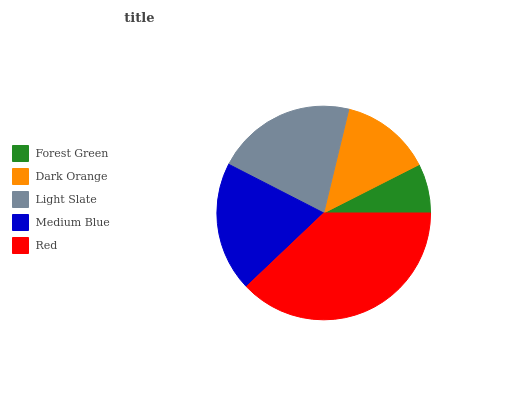Is Forest Green the minimum?
Answer yes or no. Yes. Is Red the maximum?
Answer yes or no. Yes. Is Dark Orange the minimum?
Answer yes or no. No. Is Dark Orange the maximum?
Answer yes or no. No. Is Dark Orange greater than Forest Green?
Answer yes or no. Yes. Is Forest Green less than Dark Orange?
Answer yes or no. Yes. Is Forest Green greater than Dark Orange?
Answer yes or no. No. Is Dark Orange less than Forest Green?
Answer yes or no. No. Is Medium Blue the high median?
Answer yes or no. Yes. Is Medium Blue the low median?
Answer yes or no. Yes. Is Light Slate the high median?
Answer yes or no. No. Is Forest Green the low median?
Answer yes or no. No. 